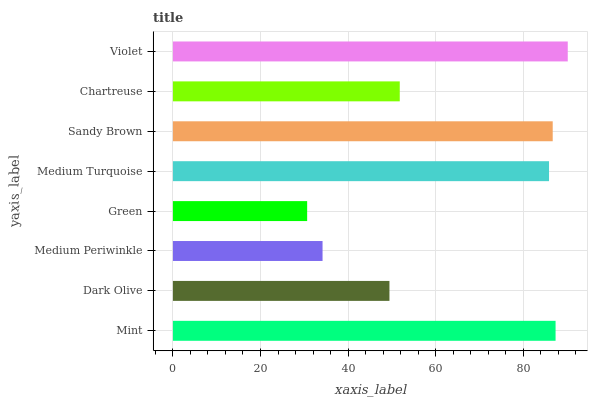Is Green the minimum?
Answer yes or no. Yes. Is Violet the maximum?
Answer yes or no. Yes. Is Dark Olive the minimum?
Answer yes or no. No. Is Dark Olive the maximum?
Answer yes or no. No. Is Mint greater than Dark Olive?
Answer yes or no. Yes. Is Dark Olive less than Mint?
Answer yes or no. Yes. Is Dark Olive greater than Mint?
Answer yes or no. No. Is Mint less than Dark Olive?
Answer yes or no. No. Is Medium Turquoise the high median?
Answer yes or no. Yes. Is Chartreuse the low median?
Answer yes or no. Yes. Is Sandy Brown the high median?
Answer yes or no. No. Is Dark Olive the low median?
Answer yes or no. No. 